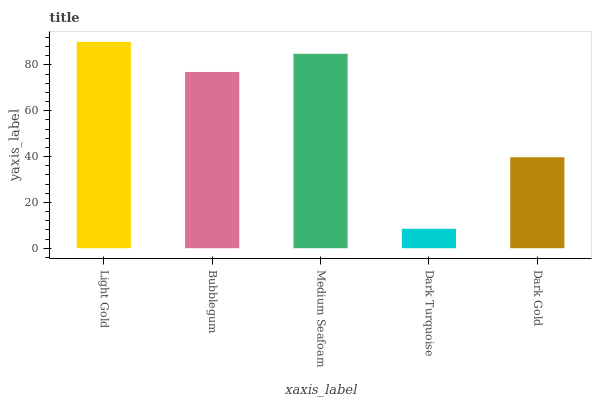Is Dark Turquoise the minimum?
Answer yes or no. Yes. Is Light Gold the maximum?
Answer yes or no. Yes. Is Bubblegum the minimum?
Answer yes or no. No. Is Bubblegum the maximum?
Answer yes or no. No. Is Light Gold greater than Bubblegum?
Answer yes or no. Yes. Is Bubblegum less than Light Gold?
Answer yes or no. Yes. Is Bubblegum greater than Light Gold?
Answer yes or no. No. Is Light Gold less than Bubblegum?
Answer yes or no. No. Is Bubblegum the high median?
Answer yes or no. Yes. Is Bubblegum the low median?
Answer yes or no. Yes. Is Medium Seafoam the high median?
Answer yes or no. No. Is Light Gold the low median?
Answer yes or no. No. 